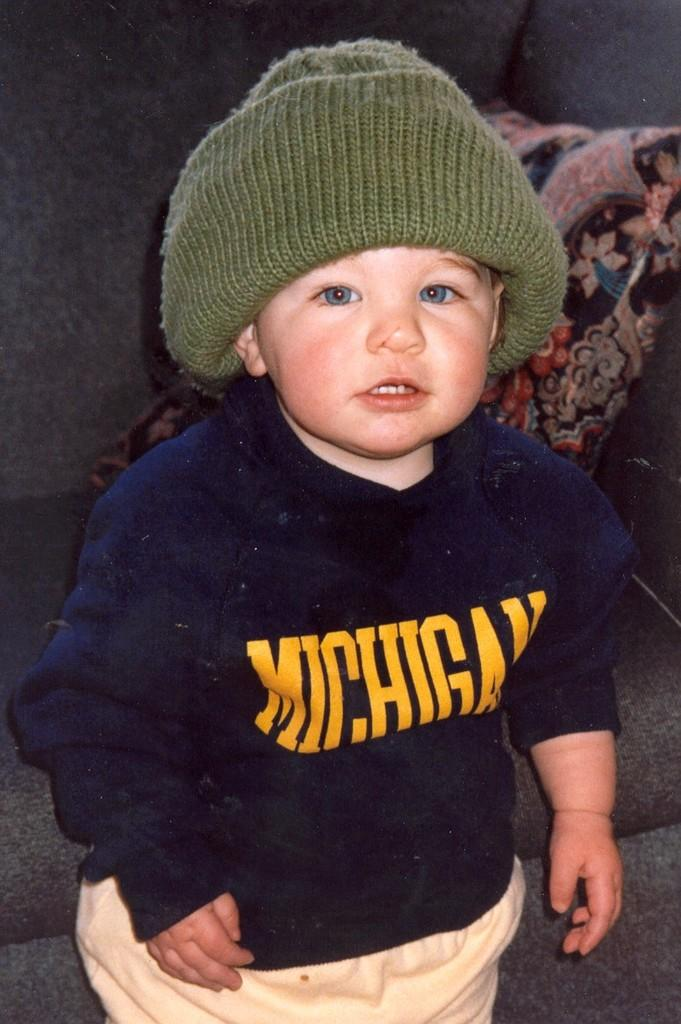Who or what is the main subject in the image? There is a person in the image. What is the person wearing? The person is wearing a navy blue and cream color dress. Can you describe any accessories the person is wearing? The person is wearing a cap. What can be seen in the background of the image? There is a pillow in the background of the image. Where is the pillow located? The pillow is on a couch. What type of toy can be seen in the person's hand in the image? There is no toy visible in the person's hand in the image. What color is the person's flesh in the image? The image does not show the person's flesh, so it cannot be determined from the image. 